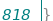<code> <loc_0><loc_0><loc_500><loc_500><_TypeScript_>}</code> 